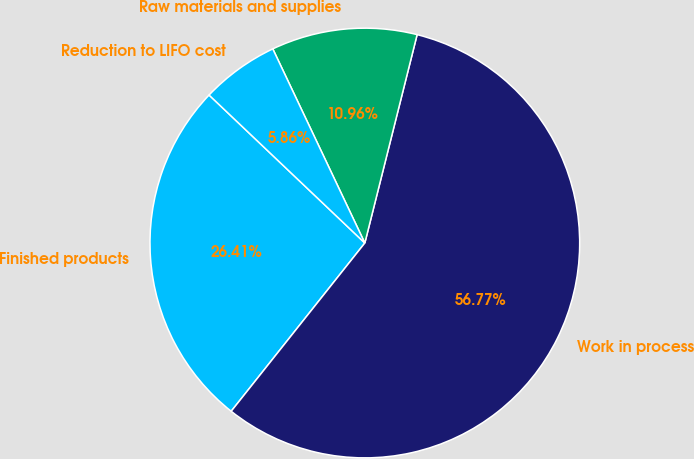Convert chart to OTSL. <chart><loc_0><loc_0><loc_500><loc_500><pie_chart><fcel>Finished products<fcel>Work in process<fcel>Raw materials and supplies<fcel>Reduction to LIFO cost<nl><fcel>26.41%<fcel>56.77%<fcel>10.96%<fcel>5.86%<nl></chart> 